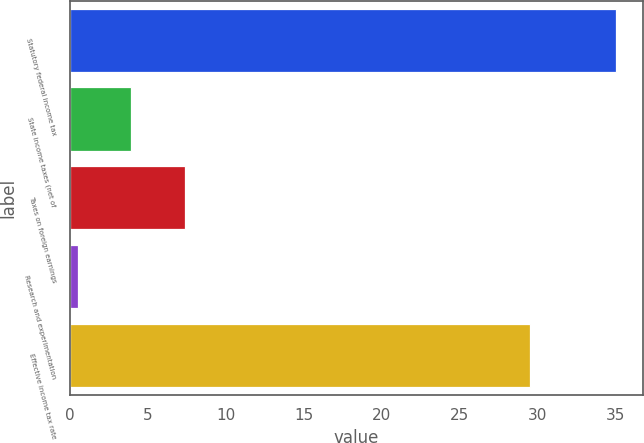<chart> <loc_0><loc_0><loc_500><loc_500><bar_chart><fcel>Statutory federal income tax<fcel>State income taxes (net of<fcel>Taxes on foreign earnings<fcel>Research and experimentation<fcel>Effective income tax rate<nl><fcel>35<fcel>3.95<fcel>7.4<fcel>0.5<fcel>29.5<nl></chart> 